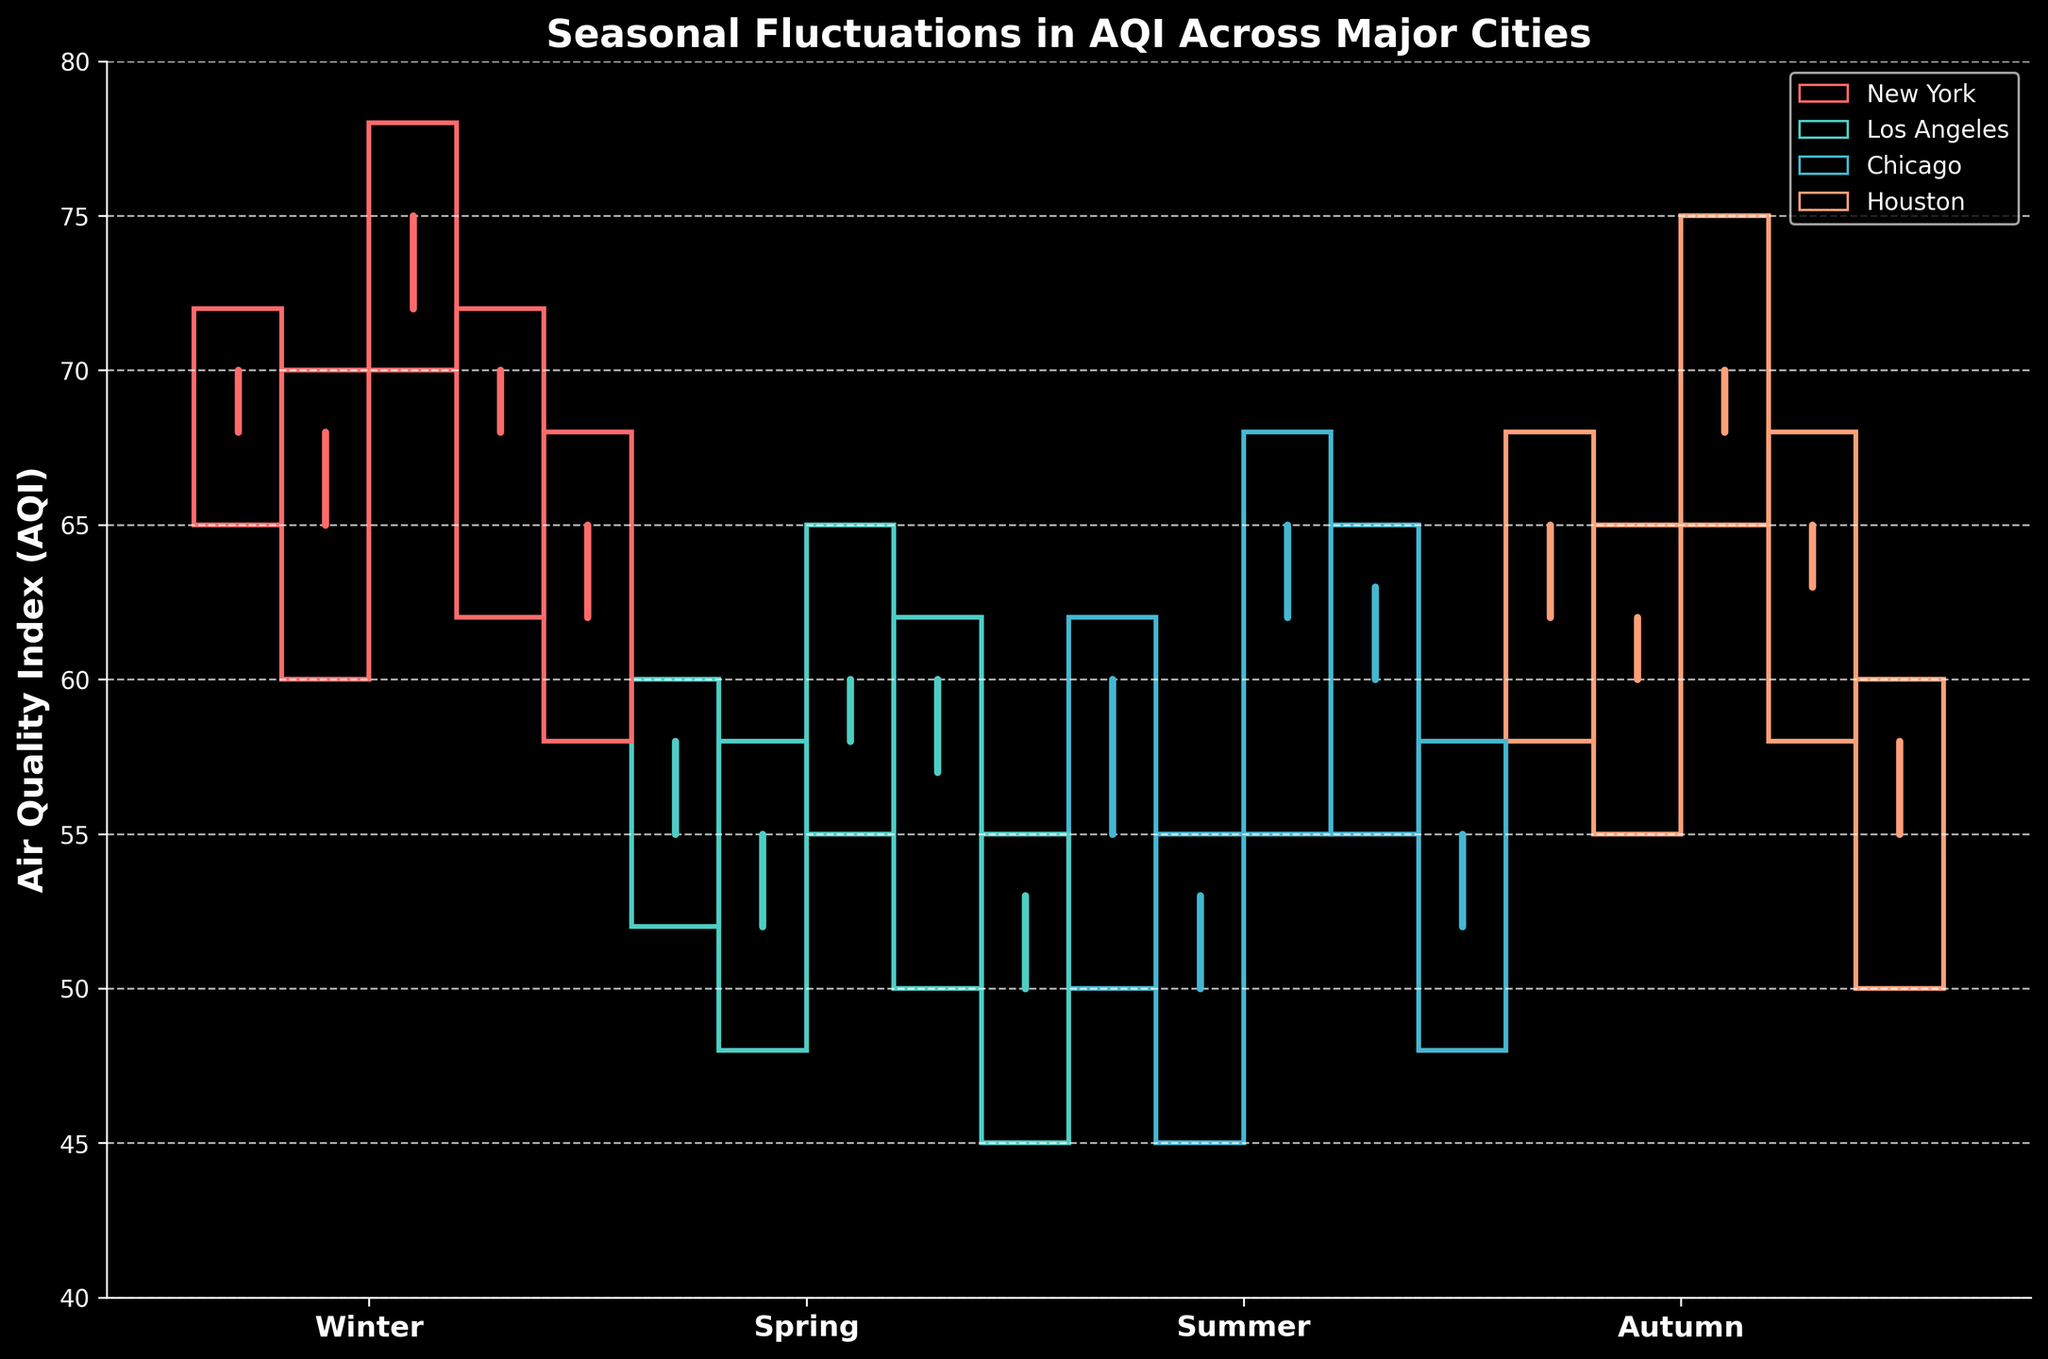How many cities are represented in the figure? The figure features AQI data for different cities, each represented by distinct sections within the chart. By counting the unique city sections represented by candlesticks, you can determine the number of cities.
Answer: 5 What season has the highest AQI in New York? In the figure, New York has four distinct candlestick sections for each season. The candlestick with the highest "high" value indicates the highest AQI. Identifying which season has the maximum value helps determine the highest AQI season.
Answer: Winter Which city has the lowest AQI value during Summer? To determine this, look at the "low" values of the summer candlesticks in each city's section. The city with the lowest value indicates the city with the lowest AQI during Summer.
Answer: Los Angeles What is the title of the figure? The title is usually displayed prominently at the top of the figure, and you can read it directly from there.
Answer: Seasonal Fluctuations in AQI Across Major Cities Which season shows the greatest variability in AQI for Chicago? Variability in AQI can be assessed by the height of the candlesticks. To find the season with the greatest variability for Chicago, look for the candlestick with the greatest difference between the "high" and "low" values.
Answer: Winter In which season do New York and Los Angeles have the same AQI closing value? For this, compare the "close" values (end of the candlestick) for New York and Los Angeles across all seasons. Identify the season where these values match.
Answer: Winter How does the AQI in Houston during Spring compare to that in Autumn? Compare the candlestick sections for Houston in Spring and Autumn by looking at the AQI values. Determine which is higher or if they are equal by comparing their high, low, open, and close values.
Answer: Autumn is higher What is the range of the AQI values for Atlanta during Winter? The range is calculated by subtracting the lowest value of the Winter candlestick from the highest value within the same season section for Atlanta.
Answer: 10 Which season shows the least variability in AQI for Atlanta? Variability is indicated by the height of the candlesticks. The season with the shortest candlestick or the smallest difference between high and low values demonstrates the least variability.
Answer: Spring What is the average "close" AQI value for Chicago across all seasons? To find this, sum up the close values for each season for Chicago (72, 58, 65, and 68), then divide by the number of seasons (4).
Answer: 65.75 